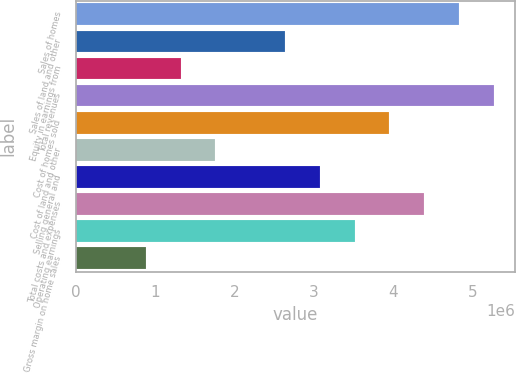<chart> <loc_0><loc_0><loc_500><loc_500><bar_chart><fcel>Sales of homes<fcel>Sales of land and other<fcel>Equity in earnings from<fcel>Total revenues<fcel>Cost of homes sold<fcel>Cost of land and other<fcel>Selling general and<fcel>Total costs and expenses<fcel>Operating earnings<fcel>Gross margin on home sales<nl><fcel>4.82904e+06<fcel>2.63402e+06<fcel>1.31702e+06<fcel>5.26804e+06<fcel>3.95103e+06<fcel>1.75602e+06<fcel>3.07303e+06<fcel>4.39003e+06<fcel>3.51203e+06<fcel>878015<nl></chart> 